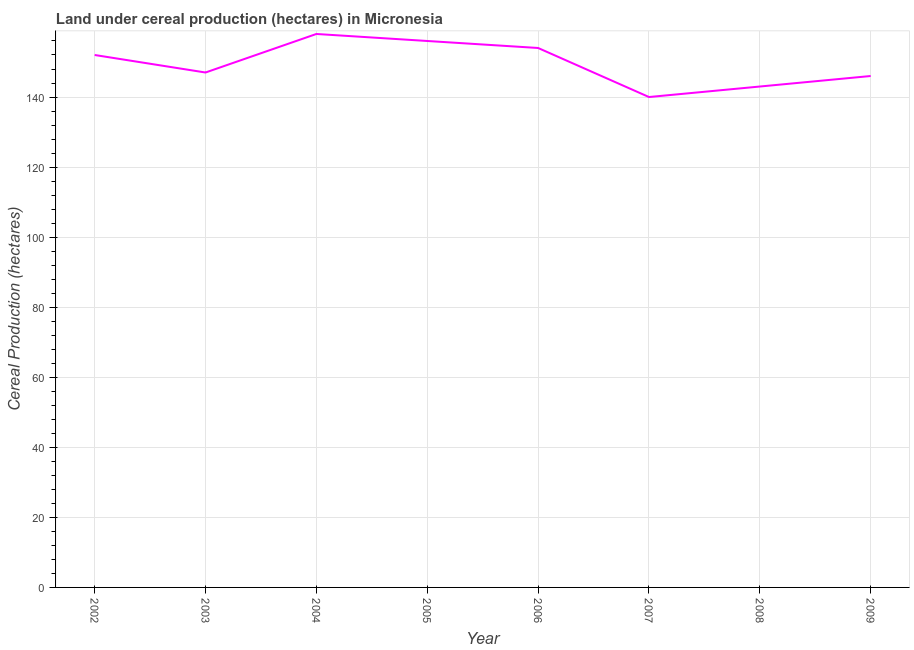What is the land under cereal production in 2003?
Your response must be concise. 147. Across all years, what is the maximum land under cereal production?
Keep it short and to the point. 158. Across all years, what is the minimum land under cereal production?
Provide a short and direct response. 140. In which year was the land under cereal production maximum?
Your answer should be compact. 2004. In which year was the land under cereal production minimum?
Your answer should be compact. 2007. What is the sum of the land under cereal production?
Give a very brief answer. 1196. What is the difference between the land under cereal production in 2007 and 2008?
Keep it short and to the point. -3. What is the average land under cereal production per year?
Offer a terse response. 149.5. What is the median land under cereal production?
Give a very brief answer. 149.5. What is the ratio of the land under cereal production in 2002 to that in 2008?
Your response must be concise. 1.06. Is the land under cereal production in 2004 less than that in 2007?
Offer a terse response. No. What is the difference between the highest and the lowest land under cereal production?
Keep it short and to the point. 18. In how many years, is the land under cereal production greater than the average land under cereal production taken over all years?
Ensure brevity in your answer.  4. How many lines are there?
Your answer should be compact. 1. Does the graph contain any zero values?
Ensure brevity in your answer.  No. What is the title of the graph?
Your response must be concise. Land under cereal production (hectares) in Micronesia. What is the label or title of the X-axis?
Give a very brief answer. Year. What is the label or title of the Y-axis?
Provide a short and direct response. Cereal Production (hectares). What is the Cereal Production (hectares) of 2002?
Offer a very short reply. 152. What is the Cereal Production (hectares) of 2003?
Offer a very short reply. 147. What is the Cereal Production (hectares) of 2004?
Give a very brief answer. 158. What is the Cereal Production (hectares) of 2005?
Your answer should be very brief. 156. What is the Cereal Production (hectares) of 2006?
Provide a short and direct response. 154. What is the Cereal Production (hectares) of 2007?
Your answer should be compact. 140. What is the Cereal Production (hectares) in 2008?
Give a very brief answer. 143. What is the Cereal Production (hectares) in 2009?
Ensure brevity in your answer.  146. What is the difference between the Cereal Production (hectares) in 2002 and 2003?
Your answer should be very brief. 5. What is the difference between the Cereal Production (hectares) in 2002 and 2006?
Your answer should be very brief. -2. What is the difference between the Cereal Production (hectares) in 2002 and 2008?
Provide a succinct answer. 9. What is the difference between the Cereal Production (hectares) in 2003 and 2004?
Offer a terse response. -11. What is the difference between the Cereal Production (hectares) in 2003 and 2005?
Your answer should be very brief. -9. What is the difference between the Cereal Production (hectares) in 2003 and 2006?
Offer a very short reply. -7. What is the difference between the Cereal Production (hectares) in 2003 and 2007?
Your answer should be very brief. 7. What is the difference between the Cereal Production (hectares) in 2003 and 2008?
Your response must be concise. 4. What is the difference between the Cereal Production (hectares) in 2004 and 2005?
Your answer should be very brief. 2. What is the difference between the Cereal Production (hectares) in 2004 and 2006?
Give a very brief answer. 4. What is the difference between the Cereal Production (hectares) in 2004 and 2008?
Offer a terse response. 15. What is the difference between the Cereal Production (hectares) in 2004 and 2009?
Your response must be concise. 12. What is the difference between the Cereal Production (hectares) in 2005 and 2007?
Provide a short and direct response. 16. What is the difference between the Cereal Production (hectares) in 2006 and 2007?
Your response must be concise. 14. What is the difference between the Cereal Production (hectares) in 2006 and 2009?
Keep it short and to the point. 8. What is the difference between the Cereal Production (hectares) in 2008 and 2009?
Offer a very short reply. -3. What is the ratio of the Cereal Production (hectares) in 2002 to that in 2003?
Provide a short and direct response. 1.03. What is the ratio of the Cereal Production (hectares) in 2002 to that in 2006?
Make the answer very short. 0.99. What is the ratio of the Cereal Production (hectares) in 2002 to that in 2007?
Provide a short and direct response. 1.09. What is the ratio of the Cereal Production (hectares) in 2002 to that in 2008?
Your response must be concise. 1.06. What is the ratio of the Cereal Production (hectares) in 2002 to that in 2009?
Offer a very short reply. 1.04. What is the ratio of the Cereal Production (hectares) in 2003 to that in 2004?
Your answer should be compact. 0.93. What is the ratio of the Cereal Production (hectares) in 2003 to that in 2005?
Your response must be concise. 0.94. What is the ratio of the Cereal Production (hectares) in 2003 to that in 2006?
Your answer should be very brief. 0.95. What is the ratio of the Cereal Production (hectares) in 2003 to that in 2008?
Provide a short and direct response. 1.03. What is the ratio of the Cereal Production (hectares) in 2004 to that in 2006?
Provide a short and direct response. 1.03. What is the ratio of the Cereal Production (hectares) in 2004 to that in 2007?
Provide a succinct answer. 1.13. What is the ratio of the Cereal Production (hectares) in 2004 to that in 2008?
Provide a short and direct response. 1.1. What is the ratio of the Cereal Production (hectares) in 2004 to that in 2009?
Offer a terse response. 1.08. What is the ratio of the Cereal Production (hectares) in 2005 to that in 2007?
Provide a short and direct response. 1.11. What is the ratio of the Cereal Production (hectares) in 2005 to that in 2008?
Your answer should be very brief. 1.09. What is the ratio of the Cereal Production (hectares) in 2005 to that in 2009?
Provide a short and direct response. 1.07. What is the ratio of the Cereal Production (hectares) in 2006 to that in 2007?
Make the answer very short. 1.1. What is the ratio of the Cereal Production (hectares) in 2006 to that in 2008?
Your answer should be very brief. 1.08. What is the ratio of the Cereal Production (hectares) in 2006 to that in 2009?
Provide a succinct answer. 1.05. What is the ratio of the Cereal Production (hectares) in 2007 to that in 2008?
Keep it short and to the point. 0.98. What is the ratio of the Cereal Production (hectares) in 2007 to that in 2009?
Your response must be concise. 0.96. What is the ratio of the Cereal Production (hectares) in 2008 to that in 2009?
Ensure brevity in your answer.  0.98. 